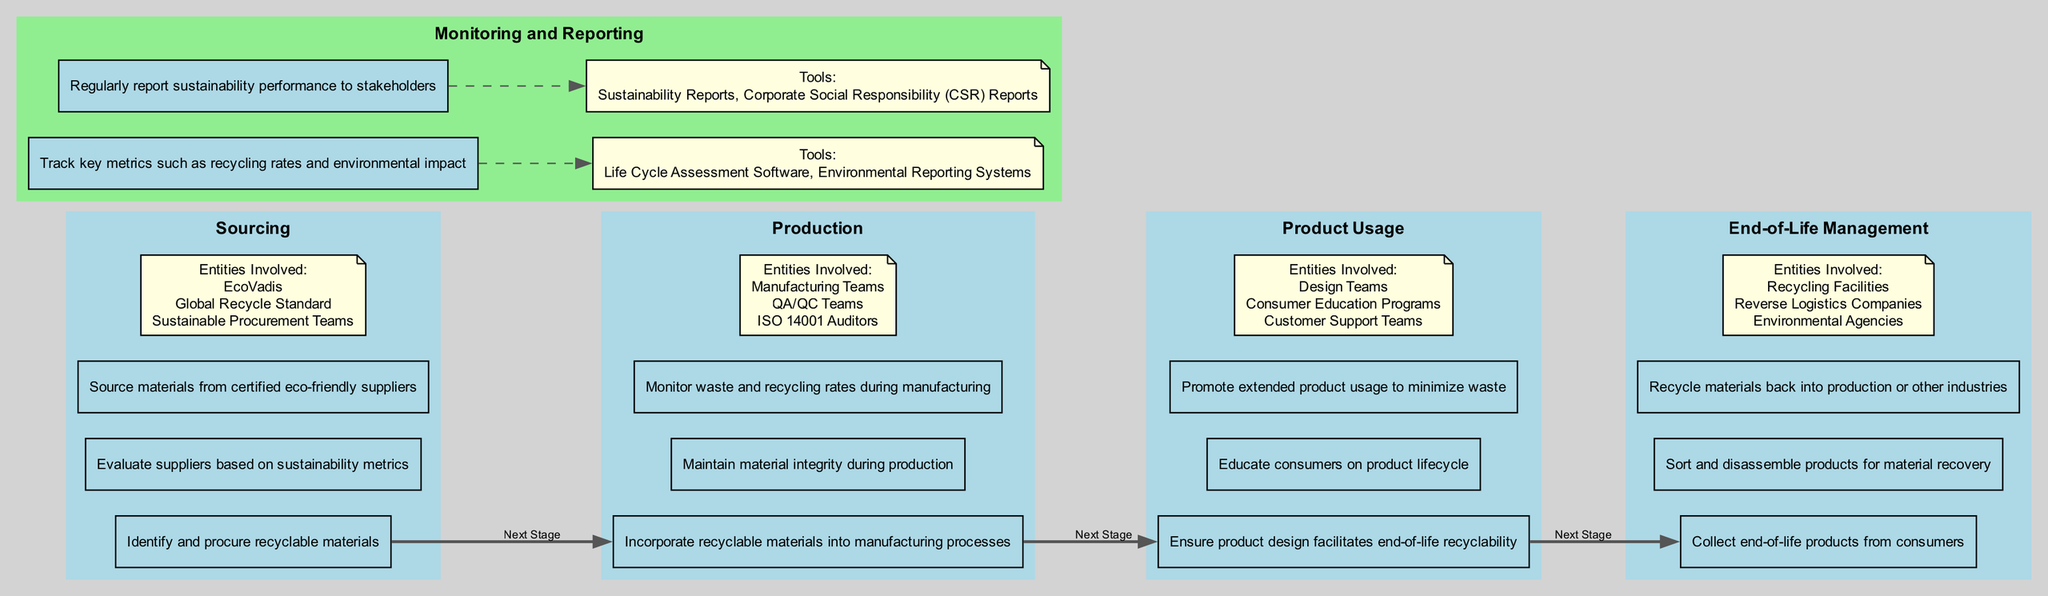What are the three main stages of the Clinical Pathway? The diagram outlines four main stages of the Clinical Pathway: Sourcing, Production, Product Usage, and End-of-Life Management.
Answer: Sourcing, Production, Product Usage, End-of-Life Management How many activities are listed under the Production stage? The diagram indicates three specific activities under the Production stage: Incorporate recyclable materials into manufacturing processes, Maintain material integrity during production, and Monitor waste and recycling rates during manufacturing.
Answer: 3 Which stage involves educating consumers? The diagram shows that educating consumers on product lifecycle is an activity listed under the Product Usage stage.
Answer: Product Usage What tool is used for tracking key metrics? According to the Monitoring and Reporting section of the diagram, Life Cycle Assessment Software is listed as a tool used for tracking key metrics such as recycling rates and environmental impact.
Answer: Life Cycle Assessment Software How does End-of-Life Management relate to Sourcing? The flow from Sourcing to End-of-Life Management indicates that materials sourced in the first stage ultimately lead to end-of-life management practices, focusing on collection, sorting, and recycling.
Answer: Collection, sorting, and recycling What is the primary goal of the Sourcing stage? The Sourcing stage aims to identify and procure recyclable materials, which emphasizes finding and evaluating sustainable suppliers.
Answer: Identify and procure recyclable materials How many entities are involved in the End-of-Life Management stage? The End-of-Life Management stage lists three entities involved: Recycling Facilities, Reverse Logistics Companies, and Environmental Agencies, making a total of three.
Answer: 3 Which activity focuses on minimizing waste during product usage? The diagram notes that promoting extended product usage to minimize waste is a specific activity under the Product Usage stage, indicating its focus on sustainability.
Answer: Promote extended product usage to minimize waste What is the output of monitoring sustainability performance? The regular reporting of sustainability performance to stakeholders results in Sustainability Reports and Corporate Social Responsibility (CSR) Reports, which summarize the organization’s environmental impact.
Answer: Sustainability Reports, CSR Reports 